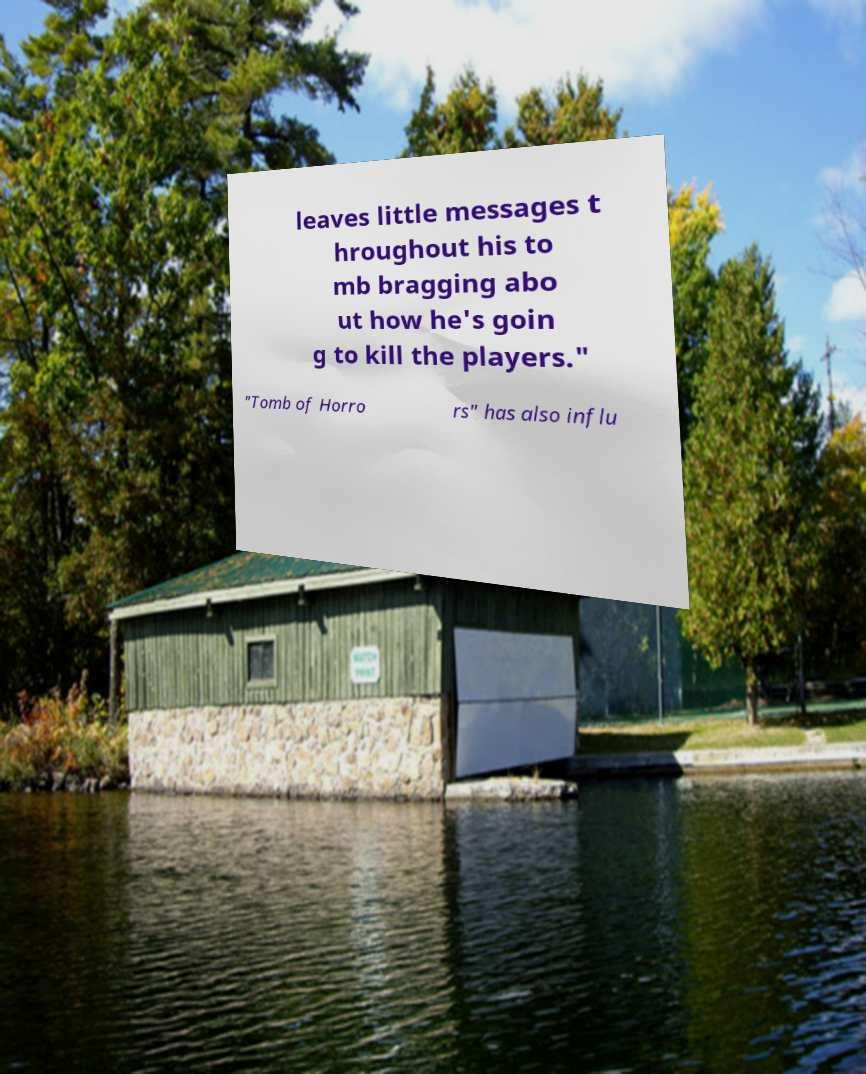Could you extract and type out the text from this image? leaves little messages t hroughout his to mb bragging abo ut how he's goin g to kill the players." "Tomb of Horro rs" has also influ 